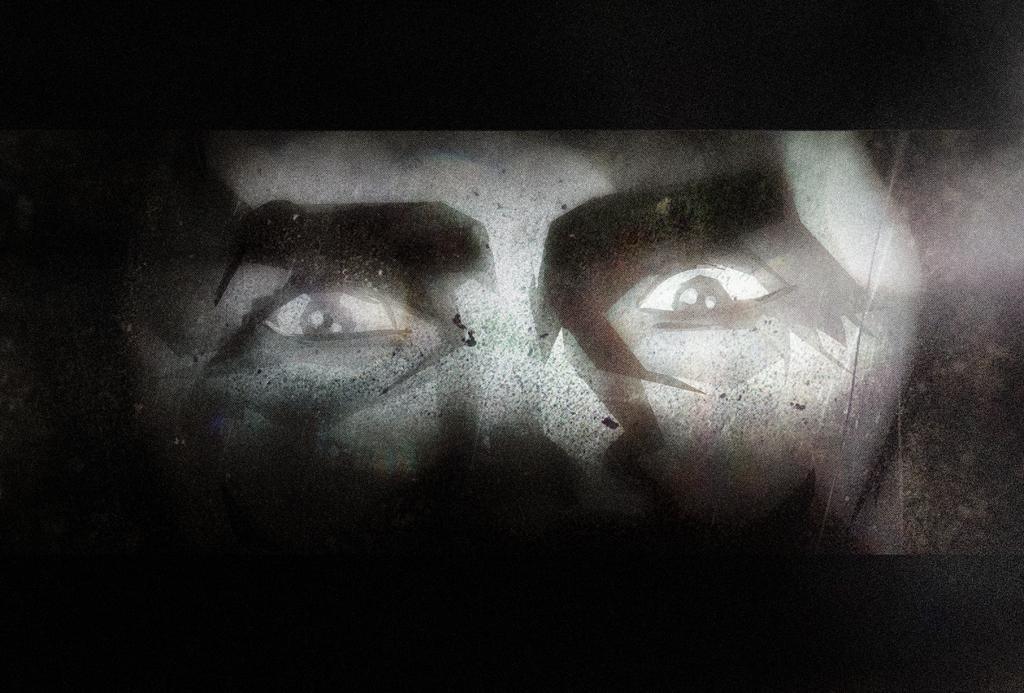How would you summarize this image in a sentence or two? In this picture we can see a person face and in the background it is dark. 